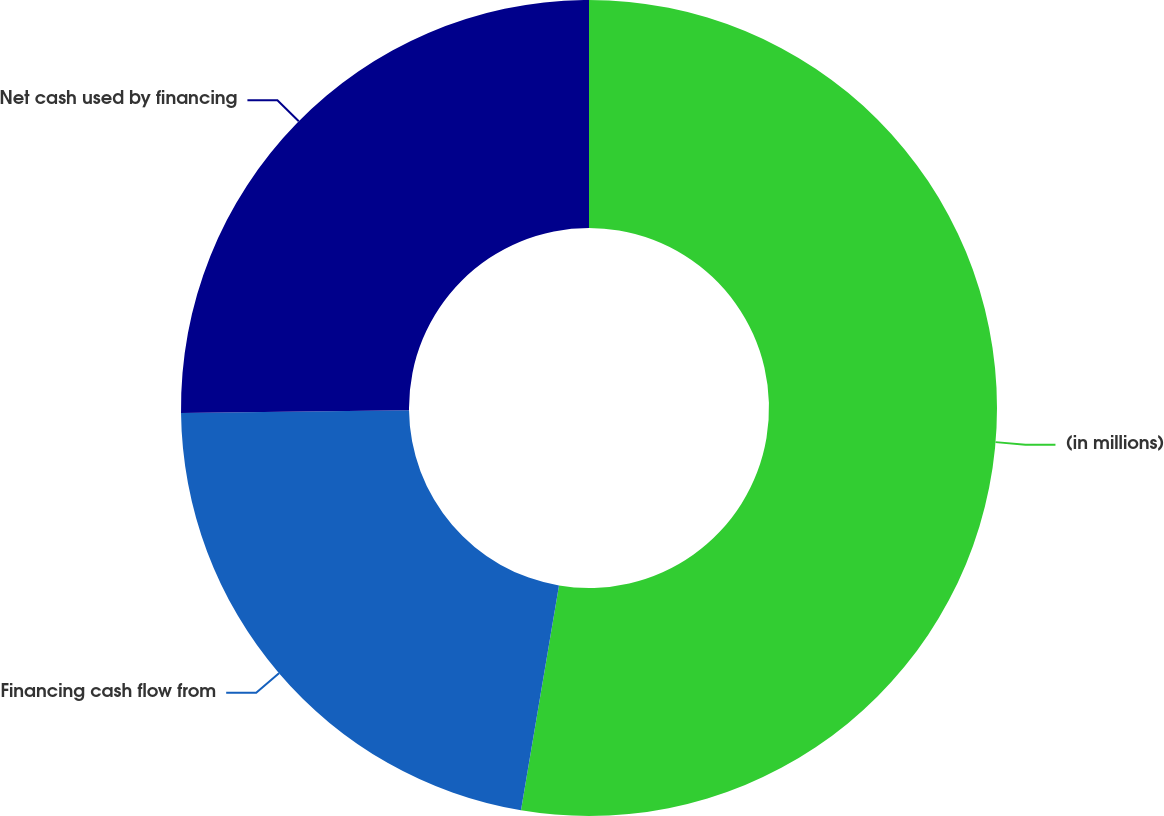Convert chart. <chart><loc_0><loc_0><loc_500><loc_500><pie_chart><fcel>(in millions)<fcel>Financing cash flow from<fcel>Net cash used by financing<nl><fcel>52.66%<fcel>22.14%<fcel>25.19%<nl></chart> 